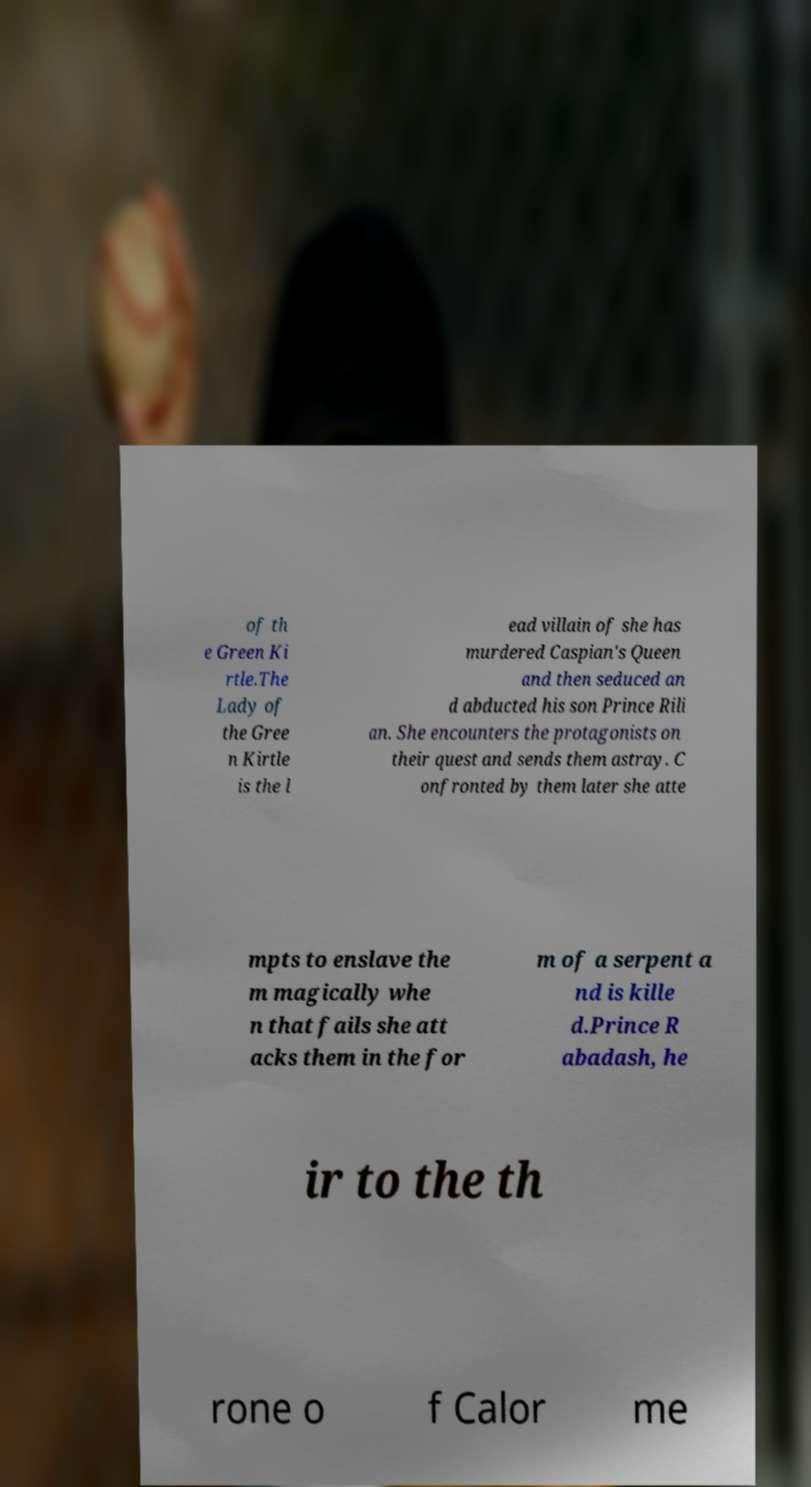I need the written content from this picture converted into text. Can you do that? of th e Green Ki rtle.The Lady of the Gree n Kirtle is the l ead villain of she has murdered Caspian's Queen and then seduced an d abducted his son Prince Rili an. She encounters the protagonists on their quest and sends them astray. C onfronted by them later she atte mpts to enslave the m magically whe n that fails she att acks them in the for m of a serpent a nd is kille d.Prince R abadash, he ir to the th rone o f Calor me 